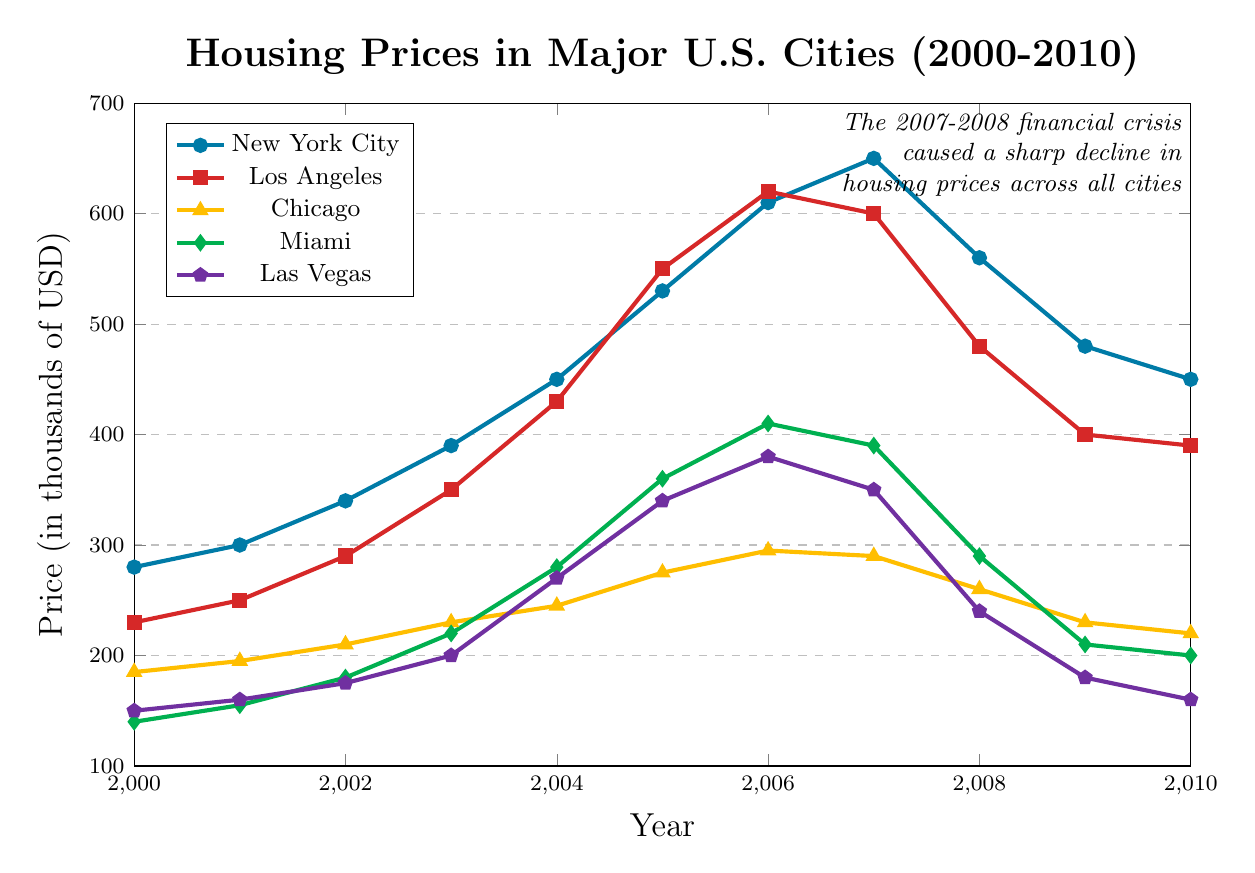What was the highest housing price in New York City, and in which year did it occur? By examining the plot, we can see that the highest point for New York City occurred in 2007, where the price reached the peak of $650,000.
Answer: $650,000 in 2007 Which city experienced the sharpest decline in housing prices between 2007 and 2010? By comparing the slopes of the lines from 2007 to 2010 for each city, we observe that Las Vegas had the steepest decline, falling from $350,000 in 2007 to $160,000 in 2010.
Answer: Las Vegas What’s the average price of housing in Miami from 2005 to 2010? The prices in Miami from 2005 to 2010 are $360,000, $410,000, $390,000, $290,000, $210,000, and $200,000. Sum these and divide by the number of years: (360 + 410 + 390 + 290 + 210 + 200) / 6 = 1860 / 6 = $310,000.
Answer: $310,000 Which city had the highest housing price in 2006, and what was it? In 2006, the prices for cities are: New York City ($610,000), Los Angeles ($620,000), Chicago ($295,000), Miami ($410,000), and Las Vegas ($380,000). Los Angeles had the highest price.
Answer: Los Angeles with $620,000 From 2000 to 2005, how much did housing prices increase in Chicago? In 2000, Chicago’s price was $185,000, and in 2005, it was $275,000. The increase is $275,000 - $185,000 = $90,000.
Answer: $90,000 Compare the housing prices in 2008 for New York City and Miami. Which city had higher prices and by how much? In 2008, New York City had $560,000, and Miami had $290,000. The difference is $560,000 - $290,000 = $270,000.
Answer: New York City by $270,000 Which year did Los Angeles surpass the $500,000 mark in housing prices? The plot shows that in 2004, Los Angeles had $430,000, and in 2005, it reached $550,000. Therefore, it surpassed the $500,000 mark in 2005.
Answer: 2005 What is the overall trend of housing prices in Las Vegas from 2000 to 2010? The housing prices in Las Vegas rose from $150,000 in 2000 to a peak of $380,000 in 2006 and then declined sharply to $160,000 in 2010. Overall, there was an initial rise followed by a significant fall.
Answer: Initial rise, then significant fall Identify the year when housing prices began to decline in Chicago after reaching their peak. The peak for Chicago was in 2006 at $295,000, and the decline began afterwards in 2007 with $290,000.
Answer: 2007 